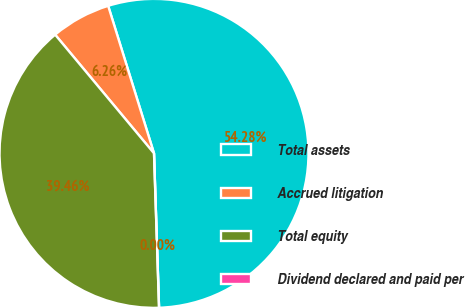Convert chart. <chart><loc_0><loc_0><loc_500><loc_500><pie_chart><fcel>Total assets<fcel>Accrued litigation<fcel>Total equity<fcel>Dividend declared and paid per<nl><fcel>54.27%<fcel>6.26%<fcel>39.46%<fcel>0.0%<nl></chart> 